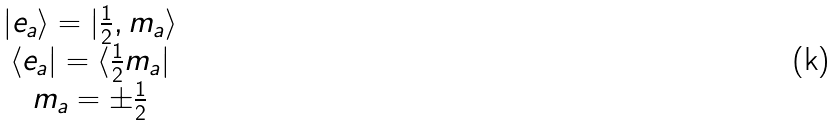Convert formula to latex. <formula><loc_0><loc_0><loc_500><loc_500>\begin{array} { c } | e _ { a } \rangle = | \frac { 1 } { 2 } , m _ { a } \rangle \\ \langle e _ { a } | = \langle \frac { 1 } { 2 } m _ { a } | \\ m _ { a } = \pm \frac { 1 } { 2 } \end{array}</formula> 